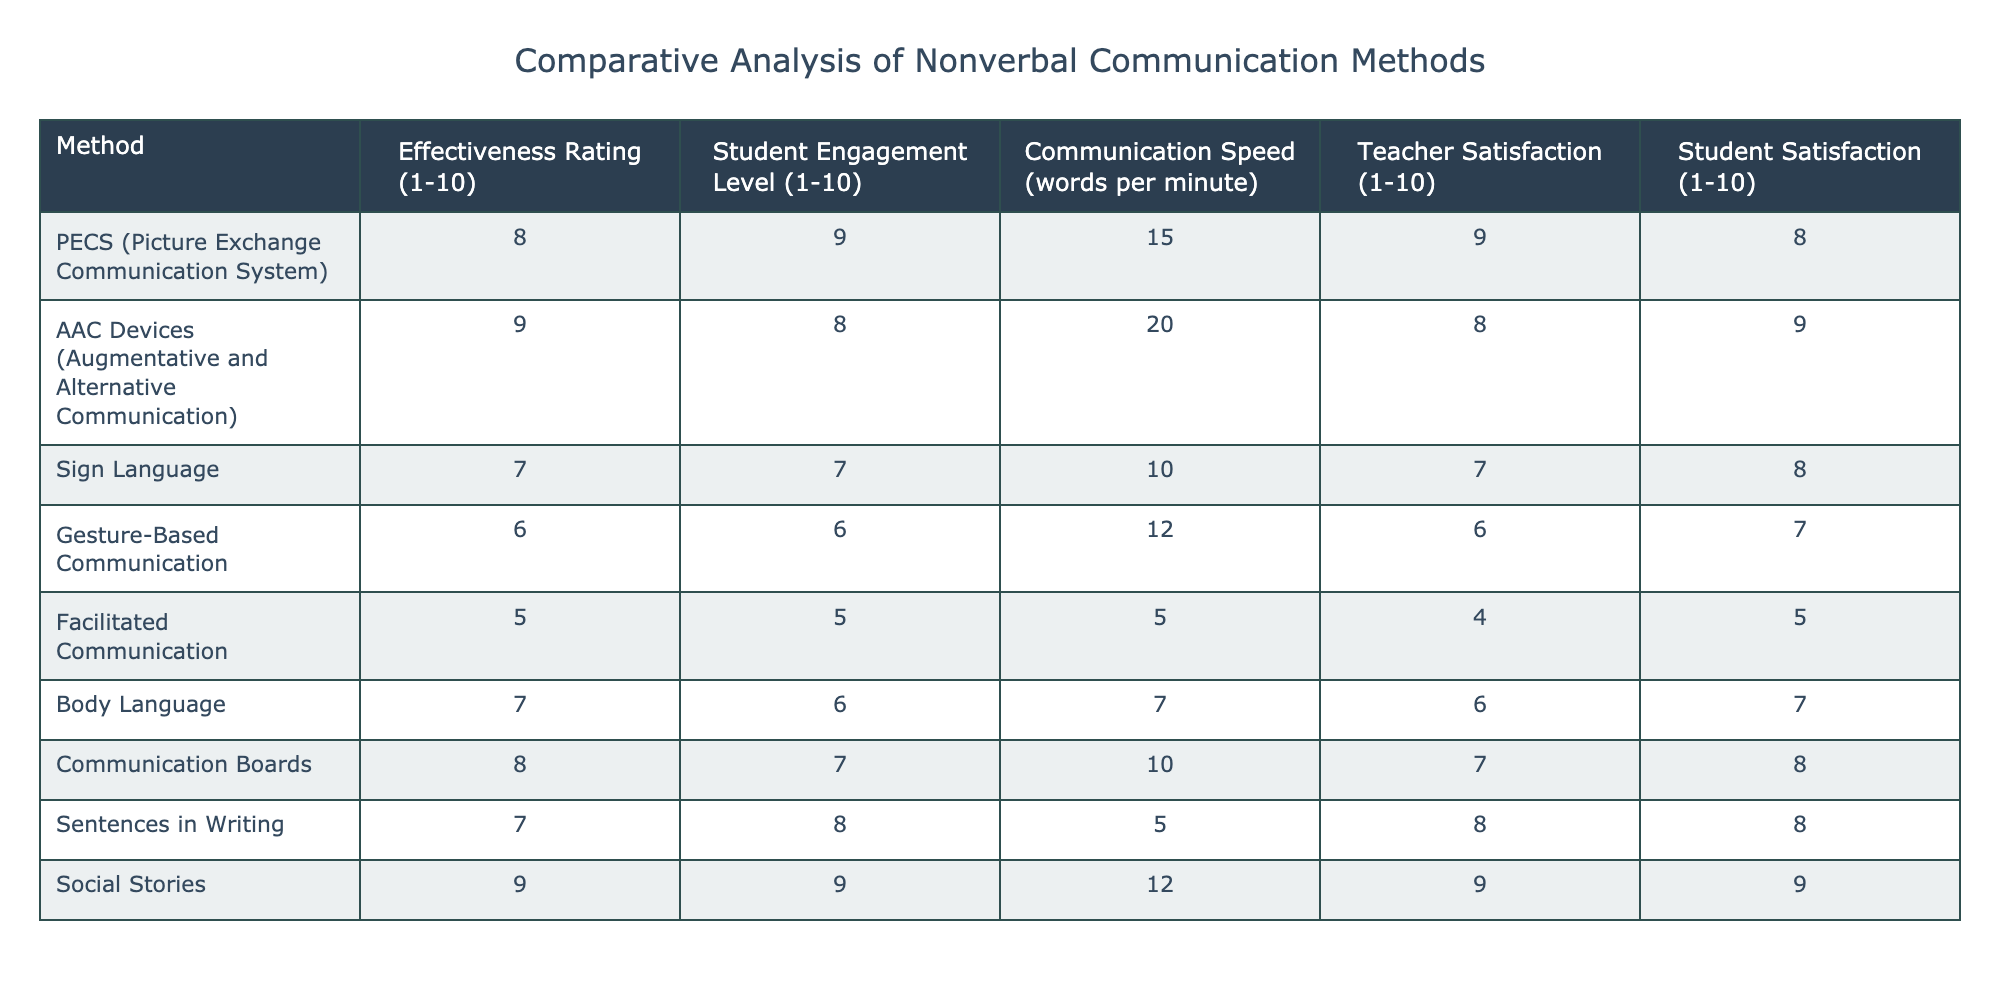What is the effectiveness rating of AAC Devices? The effectiveness rating for AAC Devices is explicitly listed in the table as 9.
Answer: 9 What communication method has the highest teacher satisfaction? The table shows teacher satisfaction ratings where Social Stories have the highest rating at 9.
Answer: 9 If we compare PECS and Gesture-Based Communication in terms of student engagement levels, which method is more effective? PECS has a student engagement level of 9, while Gesture-Based Communication has a level of 6. Since 9 is greater than 6, PECS is more effective in this aspect.
Answer: PECS What is the average communication speed of all the methods listed in the table? To find the average communication speed, we sum up the values: (15 + 20 + 10 + 12 + 5 + 7 + 10 + 5 + 12) = 91. There are 9 methods, so we divide 91 by 9, resulting in an average of approximately 10.11.
Answer: 10.11 Is it true that Body Language has a higher effectiveness rating than Facilitated Communication? Body Language's effectiveness rating is 7, and Facilitated Communication's rating is 5. Since 7 is greater than 5, the statement is true.
Answer: Yes Which two methods have the lowest student engagement levels? In the table, Gesture-Based Communication has a student engagement level of 6, and Facilitated Communication has a level of 5. These are the two lowest values.
Answer: Gesture-Based Communication and Facilitated Communication What is the difference in effectiveness rating between the most effective method and the least effective method? The most effective method is AAC Devices rated at 9, and the least effective is Facilitated Communication rated at 5. The difference is 9 - 5 = 4.
Answer: 4 Which communication method has the highest student satisfaction and what is the rating? Social Stories have the highest student satisfaction rating of 9, as indicated in the table, which can be compared to the other methods.
Answer: Social Stories, 9 How many methods have an effectiveness rating of 7 or higher? The methods with ratings of 7 or higher are PECS (8), AAC Devices (9), Communication Boards (8), Social Stories (9), and Body Language (7). There are 5 methods in total.
Answer: 5 